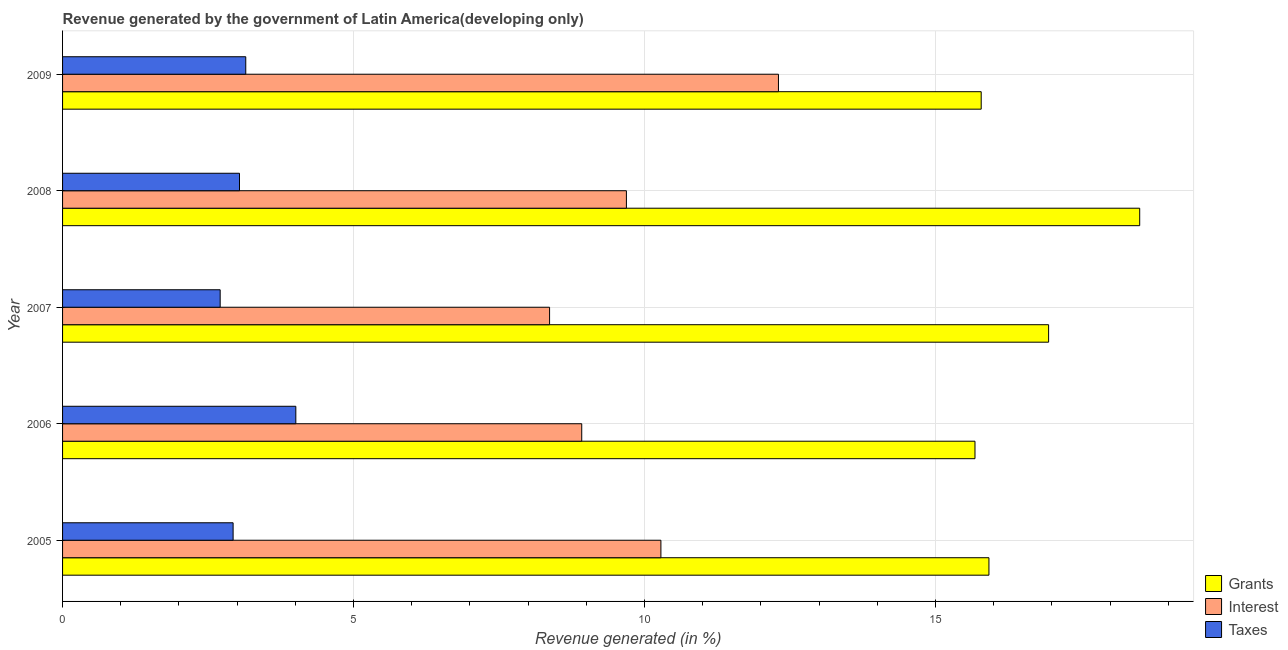How many different coloured bars are there?
Make the answer very short. 3. How many groups of bars are there?
Offer a very short reply. 5. Are the number of bars per tick equal to the number of legend labels?
Your response must be concise. Yes. Are the number of bars on each tick of the Y-axis equal?
Make the answer very short. Yes. In how many cases, is the number of bars for a given year not equal to the number of legend labels?
Keep it short and to the point. 0. What is the percentage of revenue generated by taxes in 2009?
Your answer should be compact. 3.15. Across all years, what is the maximum percentage of revenue generated by taxes?
Offer a terse response. 4.01. Across all years, what is the minimum percentage of revenue generated by interest?
Provide a succinct answer. 8.37. What is the total percentage of revenue generated by taxes in the graph?
Provide a succinct answer. 15.83. What is the difference between the percentage of revenue generated by interest in 2005 and that in 2009?
Your response must be concise. -2.02. What is the difference between the percentage of revenue generated by interest in 2009 and the percentage of revenue generated by grants in 2008?
Your response must be concise. -6.21. What is the average percentage of revenue generated by taxes per year?
Make the answer very short. 3.17. In the year 2005, what is the difference between the percentage of revenue generated by grants and percentage of revenue generated by interest?
Give a very brief answer. 5.64. In how many years, is the percentage of revenue generated by interest greater than 3 %?
Make the answer very short. 5. What is the ratio of the percentage of revenue generated by grants in 2007 to that in 2009?
Your answer should be compact. 1.07. Is the percentage of revenue generated by taxes in 2006 less than that in 2008?
Make the answer very short. No. Is the difference between the percentage of revenue generated by grants in 2008 and 2009 greater than the difference between the percentage of revenue generated by taxes in 2008 and 2009?
Make the answer very short. Yes. What is the difference between the highest and the second highest percentage of revenue generated by taxes?
Your answer should be compact. 0.86. What is the difference between the highest and the lowest percentage of revenue generated by interest?
Your answer should be very brief. 3.93. What does the 1st bar from the top in 2009 represents?
Your answer should be very brief. Taxes. What does the 2nd bar from the bottom in 2005 represents?
Offer a terse response. Interest. Are all the bars in the graph horizontal?
Offer a very short reply. Yes. Are the values on the major ticks of X-axis written in scientific E-notation?
Ensure brevity in your answer.  No. What is the title of the graph?
Keep it short and to the point. Revenue generated by the government of Latin America(developing only). What is the label or title of the X-axis?
Keep it short and to the point. Revenue generated (in %). What is the label or title of the Y-axis?
Provide a succinct answer. Year. What is the Revenue generated (in %) of Grants in 2005?
Offer a very short reply. 15.92. What is the Revenue generated (in %) of Interest in 2005?
Your answer should be very brief. 10.28. What is the Revenue generated (in %) of Taxes in 2005?
Provide a succinct answer. 2.93. What is the Revenue generated (in %) in Grants in 2006?
Your answer should be very brief. 15.68. What is the Revenue generated (in %) in Interest in 2006?
Your response must be concise. 8.92. What is the Revenue generated (in %) in Taxes in 2006?
Make the answer very short. 4.01. What is the Revenue generated (in %) in Grants in 2007?
Give a very brief answer. 16.94. What is the Revenue generated (in %) of Interest in 2007?
Give a very brief answer. 8.37. What is the Revenue generated (in %) of Taxes in 2007?
Offer a very short reply. 2.71. What is the Revenue generated (in %) of Grants in 2008?
Offer a terse response. 18.51. What is the Revenue generated (in %) in Interest in 2008?
Provide a short and direct response. 9.69. What is the Revenue generated (in %) in Taxes in 2008?
Offer a terse response. 3.04. What is the Revenue generated (in %) in Grants in 2009?
Provide a short and direct response. 15.78. What is the Revenue generated (in %) in Interest in 2009?
Your answer should be very brief. 12.3. What is the Revenue generated (in %) in Taxes in 2009?
Provide a short and direct response. 3.15. Across all years, what is the maximum Revenue generated (in %) of Grants?
Keep it short and to the point. 18.51. Across all years, what is the maximum Revenue generated (in %) of Interest?
Provide a short and direct response. 12.3. Across all years, what is the maximum Revenue generated (in %) of Taxes?
Ensure brevity in your answer.  4.01. Across all years, what is the minimum Revenue generated (in %) of Grants?
Ensure brevity in your answer.  15.68. Across all years, what is the minimum Revenue generated (in %) in Interest?
Make the answer very short. 8.37. Across all years, what is the minimum Revenue generated (in %) of Taxes?
Give a very brief answer. 2.71. What is the total Revenue generated (in %) in Grants in the graph?
Provide a succinct answer. 82.83. What is the total Revenue generated (in %) of Interest in the graph?
Offer a very short reply. 49.56. What is the total Revenue generated (in %) in Taxes in the graph?
Make the answer very short. 15.83. What is the difference between the Revenue generated (in %) of Grants in 2005 and that in 2006?
Provide a succinct answer. 0.24. What is the difference between the Revenue generated (in %) in Interest in 2005 and that in 2006?
Offer a terse response. 1.36. What is the difference between the Revenue generated (in %) in Taxes in 2005 and that in 2006?
Provide a succinct answer. -1.08. What is the difference between the Revenue generated (in %) of Grants in 2005 and that in 2007?
Keep it short and to the point. -1.03. What is the difference between the Revenue generated (in %) in Interest in 2005 and that in 2007?
Give a very brief answer. 1.91. What is the difference between the Revenue generated (in %) of Taxes in 2005 and that in 2007?
Keep it short and to the point. 0.22. What is the difference between the Revenue generated (in %) of Grants in 2005 and that in 2008?
Give a very brief answer. -2.59. What is the difference between the Revenue generated (in %) in Interest in 2005 and that in 2008?
Offer a very short reply. 0.59. What is the difference between the Revenue generated (in %) of Taxes in 2005 and that in 2008?
Offer a terse response. -0.11. What is the difference between the Revenue generated (in %) in Grants in 2005 and that in 2009?
Offer a very short reply. 0.13. What is the difference between the Revenue generated (in %) in Interest in 2005 and that in 2009?
Provide a succinct answer. -2.02. What is the difference between the Revenue generated (in %) of Taxes in 2005 and that in 2009?
Provide a succinct answer. -0.22. What is the difference between the Revenue generated (in %) in Grants in 2006 and that in 2007?
Ensure brevity in your answer.  -1.26. What is the difference between the Revenue generated (in %) in Interest in 2006 and that in 2007?
Your answer should be compact. 0.55. What is the difference between the Revenue generated (in %) in Taxes in 2006 and that in 2007?
Make the answer very short. 1.3. What is the difference between the Revenue generated (in %) in Grants in 2006 and that in 2008?
Your answer should be compact. -2.83. What is the difference between the Revenue generated (in %) of Interest in 2006 and that in 2008?
Your response must be concise. -0.77. What is the difference between the Revenue generated (in %) of Taxes in 2006 and that in 2008?
Your response must be concise. 0.97. What is the difference between the Revenue generated (in %) in Grants in 2006 and that in 2009?
Your answer should be compact. -0.11. What is the difference between the Revenue generated (in %) in Interest in 2006 and that in 2009?
Your answer should be very brief. -3.38. What is the difference between the Revenue generated (in %) of Taxes in 2006 and that in 2009?
Provide a succinct answer. 0.86. What is the difference between the Revenue generated (in %) of Grants in 2007 and that in 2008?
Offer a terse response. -1.57. What is the difference between the Revenue generated (in %) in Interest in 2007 and that in 2008?
Your response must be concise. -1.32. What is the difference between the Revenue generated (in %) of Taxes in 2007 and that in 2008?
Make the answer very short. -0.33. What is the difference between the Revenue generated (in %) of Grants in 2007 and that in 2009?
Your answer should be very brief. 1.16. What is the difference between the Revenue generated (in %) of Interest in 2007 and that in 2009?
Offer a very short reply. -3.93. What is the difference between the Revenue generated (in %) in Taxes in 2007 and that in 2009?
Keep it short and to the point. -0.44. What is the difference between the Revenue generated (in %) of Grants in 2008 and that in 2009?
Offer a very short reply. 2.72. What is the difference between the Revenue generated (in %) of Interest in 2008 and that in 2009?
Provide a short and direct response. -2.61. What is the difference between the Revenue generated (in %) in Taxes in 2008 and that in 2009?
Provide a succinct answer. -0.11. What is the difference between the Revenue generated (in %) of Grants in 2005 and the Revenue generated (in %) of Interest in 2006?
Your answer should be very brief. 7. What is the difference between the Revenue generated (in %) of Grants in 2005 and the Revenue generated (in %) of Taxes in 2006?
Your answer should be compact. 11.91. What is the difference between the Revenue generated (in %) of Interest in 2005 and the Revenue generated (in %) of Taxes in 2006?
Offer a very short reply. 6.27. What is the difference between the Revenue generated (in %) of Grants in 2005 and the Revenue generated (in %) of Interest in 2007?
Ensure brevity in your answer.  7.55. What is the difference between the Revenue generated (in %) in Grants in 2005 and the Revenue generated (in %) in Taxes in 2007?
Make the answer very short. 13.21. What is the difference between the Revenue generated (in %) in Interest in 2005 and the Revenue generated (in %) in Taxes in 2007?
Your response must be concise. 7.57. What is the difference between the Revenue generated (in %) of Grants in 2005 and the Revenue generated (in %) of Interest in 2008?
Your response must be concise. 6.23. What is the difference between the Revenue generated (in %) of Grants in 2005 and the Revenue generated (in %) of Taxes in 2008?
Keep it short and to the point. 12.88. What is the difference between the Revenue generated (in %) in Interest in 2005 and the Revenue generated (in %) in Taxes in 2008?
Offer a very short reply. 7.24. What is the difference between the Revenue generated (in %) in Grants in 2005 and the Revenue generated (in %) in Interest in 2009?
Give a very brief answer. 3.62. What is the difference between the Revenue generated (in %) of Grants in 2005 and the Revenue generated (in %) of Taxes in 2009?
Ensure brevity in your answer.  12.77. What is the difference between the Revenue generated (in %) in Interest in 2005 and the Revenue generated (in %) in Taxes in 2009?
Your response must be concise. 7.13. What is the difference between the Revenue generated (in %) of Grants in 2006 and the Revenue generated (in %) of Interest in 2007?
Your answer should be compact. 7.31. What is the difference between the Revenue generated (in %) in Grants in 2006 and the Revenue generated (in %) in Taxes in 2007?
Offer a very short reply. 12.97. What is the difference between the Revenue generated (in %) of Interest in 2006 and the Revenue generated (in %) of Taxes in 2007?
Provide a succinct answer. 6.21. What is the difference between the Revenue generated (in %) of Grants in 2006 and the Revenue generated (in %) of Interest in 2008?
Make the answer very short. 5.99. What is the difference between the Revenue generated (in %) of Grants in 2006 and the Revenue generated (in %) of Taxes in 2008?
Keep it short and to the point. 12.64. What is the difference between the Revenue generated (in %) in Interest in 2006 and the Revenue generated (in %) in Taxes in 2008?
Ensure brevity in your answer.  5.88. What is the difference between the Revenue generated (in %) of Grants in 2006 and the Revenue generated (in %) of Interest in 2009?
Your answer should be compact. 3.38. What is the difference between the Revenue generated (in %) of Grants in 2006 and the Revenue generated (in %) of Taxes in 2009?
Provide a short and direct response. 12.53. What is the difference between the Revenue generated (in %) in Interest in 2006 and the Revenue generated (in %) in Taxes in 2009?
Your answer should be compact. 5.77. What is the difference between the Revenue generated (in %) of Grants in 2007 and the Revenue generated (in %) of Interest in 2008?
Make the answer very short. 7.25. What is the difference between the Revenue generated (in %) of Grants in 2007 and the Revenue generated (in %) of Taxes in 2008?
Your answer should be compact. 13.9. What is the difference between the Revenue generated (in %) in Interest in 2007 and the Revenue generated (in %) in Taxes in 2008?
Your answer should be very brief. 5.33. What is the difference between the Revenue generated (in %) in Grants in 2007 and the Revenue generated (in %) in Interest in 2009?
Provide a succinct answer. 4.64. What is the difference between the Revenue generated (in %) in Grants in 2007 and the Revenue generated (in %) in Taxes in 2009?
Keep it short and to the point. 13.79. What is the difference between the Revenue generated (in %) in Interest in 2007 and the Revenue generated (in %) in Taxes in 2009?
Your response must be concise. 5.22. What is the difference between the Revenue generated (in %) in Grants in 2008 and the Revenue generated (in %) in Interest in 2009?
Offer a very short reply. 6.21. What is the difference between the Revenue generated (in %) in Grants in 2008 and the Revenue generated (in %) in Taxes in 2009?
Ensure brevity in your answer.  15.36. What is the difference between the Revenue generated (in %) in Interest in 2008 and the Revenue generated (in %) in Taxes in 2009?
Ensure brevity in your answer.  6.54. What is the average Revenue generated (in %) in Grants per year?
Offer a very short reply. 16.57. What is the average Revenue generated (in %) in Interest per year?
Your answer should be compact. 9.91. What is the average Revenue generated (in %) in Taxes per year?
Keep it short and to the point. 3.17. In the year 2005, what is the difference between the Revenue generated (in %) of Grants and Revenue generated (in %) of Interest?
Provide a short and direct response. 5.64. In the year 2005, what is the difference between the Revenue generated (in %) in Grants and Revenue generated (in %) in Taxes?
Provide a succinct answer. 12.99. In the year 2005, what is the difference between the Revenue generated (in %) of Interest and Revenue generated (in %) of Taxes?
Provide a short and direct response. 7.35. In the year 2006, what is the difference between the Revenue generated (in %) in Grants and Revenue generated (in %) in Interest?
Offer a terse response. 6.76. In the year 2006, what is the difference between the Revenue generated (in %) of Grants and Revenue generated (in %) of Taxes?
Offer a very short reply. 11.67. In the year 2006, what is the difference between the Revenue generated (in %) in Interest and Revenue generated (in %) in Taxes?
Keep it short and to the point. 4.91. In the year 2007, what is the difference between the Revenue generated (in %) in Grants and Revenue generated (in %) in Interest?
Make the answer very short. 8.57. In the year 2007, what is the difference between the Revenue generated (in %) in Grants and Revenue generated (in %) in Taxes?
Offer a very short reply. 14.23. In the year 2007, what is the difference between the Revenue generated (in %) of Interest and Revenue generated (in %) of Taxes?
Offer a terse response. 5.66. In the year 2008, what is the difference between the Revenue generated (in %) in Grants and Revenue generated (in %) in Interest?
Provide a short and direct response. 8.82. In the year 2008, what is the difference between the Revenue generated (in %) in Grants and Revenue generated (in %) in Taxes?
Give a very brief answer. 15.47. In the year 2008, what is the difference between the Revenue generated (in %) in Interest and Revenue generated (in %) in Taxes?
Your answer should be compact. 6.65. In the year 2009, what is the difference between the Revenue generated (in %) in Grants and Revenue generated (in %) in Interest?
Keep it short and to the point. 3.48. In the year 2009, what is the difference between the Revenue generated (in %) in Grants and Revenue generated (in %) in Taxes?
Your answer should be compact. 12.64. In the year 2009, what is the difference between the Revenue generated (in %) in Interest and Revenue generated (in %) in Taxes?
Your response must be concise. 9.15. What is the ratio of the Revenue generated (in %) in Grants in 2005 to that in 2006?
Provide a short and direct response. 1.02. What is the ratio of the Revenue generated (in %) in Interest in 2005 to that in 2006?
Your answer should be very brief. 1.15. What is the ratio of the Revenue generated (in %) of Taxes in 2005 to that in 2006?
Keep it short and to the point. 0.73. What is the ratio of the Revenue generated (in %) in Grants in 2005 to that in 2007?
Offer a very short reply. 0.94. What is the ratio of the Revenue generated (in %) in Interest in 2005 to that in 2007?
Make the answer very short. 1.23. What is the ratio of the Revenue generated (in %) in Taxes in 2005 to that in 2007?
Provide a short and direct response. 1.08. What is the ratio of the Revenue generated (in %) of Grants in 2005 to that in 2008?
Give a very brief answer. 0.86. What is the ratio of the Revenue generated (in %) of Interest in 2005 to that in 2008?
Offer a very short reply. 1.06. What is the ratio of the Revenue generated (in %) in Taxes in 2005 to that in 2008?
Your response must be concise. 0.96. What is the ratio of the Revenue generated (in %) of Grants in 2005 to that in 2009?
Your answer should be compact. 1.01. What is the ratio of the Revenue generated (in %) of Interest in 2005 to that in 2009?
Your answer should be very brief. 0.84. What is the ratio of the Revenue generated (in %) of Taxes in 2005 to that in 2009?
Your answer should be very brief. 0.93. What is the ratio of the Revenue generated (in %) in Grants in 2006 to that in 2007?
Your answer should be compact. 0.93. What is the ratio of the Revenue generated (in %) of Interest in 2006 to that in 2007?
Ensure brevity in your answer.  1.07. What is the ratio of the Revenue generated (in %) of Taxes in 2006 to that in 2007?
Keep it short and to the point. 1.48. What is the ratio of the Revenue generated (in %) of Grants in 2006 to that in 2008?
Provide a short and direct response. 0.85. What is the ratio of the Revenue generated (in %) of Interest in 2006 to that in 2008?
Give a very brief answer. 0.92. What is the ratio of the Revenue generated (in %) in Taxes in 2006 to that in 2008?
Your answer should be compact. 1.32. What is the ratio of the Revenue generated (in %) in Grants in 2006 to that in 2009?
Your answer should be compact. 0.99. What is the ratio of the Revenue generated (in %) of Interest in 2006 to that in 2009?
Give a very brief answer. 0.73. What is the ratio of the Revenue generated (in %) of Taxes in 2006 to that in 2009?
Your answer should be very brief. 1.27. What is the ratio of the Revenue generated (in %) of Grants in 2007 to that in 2008?
Ensure brevity in your answer.  0.92. What is the ratio of the Revenue generated (in %) in Interest in 2007 to that in 2008?
Your answer should be very brief. 0.86. What is the ratio of the Revenue generated (in %) of Taxes in 2007 to that in 2008?
Provide a succinct answer. 0.89. What is the ratio of the Revenue generated (in %) in Grants in 2007 to that in 2009?
Your answer should be compact. 1.07. What is the ratio of the Revenue generated (in %) of Interest in 2007 to that in 2009?
Make the answer very short. 0.68. What is the ratio of the Revenue generated (in %) of Taxes in 2007 to that in 2009?
Offer a terse response. 0.86. What is the ratio of the Revenue generated (in %) of Grants in 2008 to that in 2009?
Provide a succinct answer. 1.17. What is the ratio of the Revenue generated (in %) of Interest in 2008 to that in 2009?
Give a very brief answer. 0.79. What is the ratio of the Revenue generated (in %) of Taxes in 2008 to that in 2009?
Your response must be concise. 0.97. What is the difference between the highest and the second highest Revenue generated (in %) of Grants?
Keep it short and to the point. 1.57. What is the difference between the highest and the second highest Revenue generated (in %) of Interest?
Offer a terse response. 2.02. What is the difference between the highest and the second highest Revenue generated (in %) in Taxes?
Make the answer very short. 0.86. What is the difference between the highest and the lowest Revenue generated (in %) of Grants?
Make the answer very short. 2.83. What is the difference between the highest and the lowest Revenue generated (in %) in Interest?
Ensure brevity in your answer.  3.93. What is the difference between the highest and the lowest Revenue generated (in %) of Taxes?
Offer a very short reply. 1.3. 